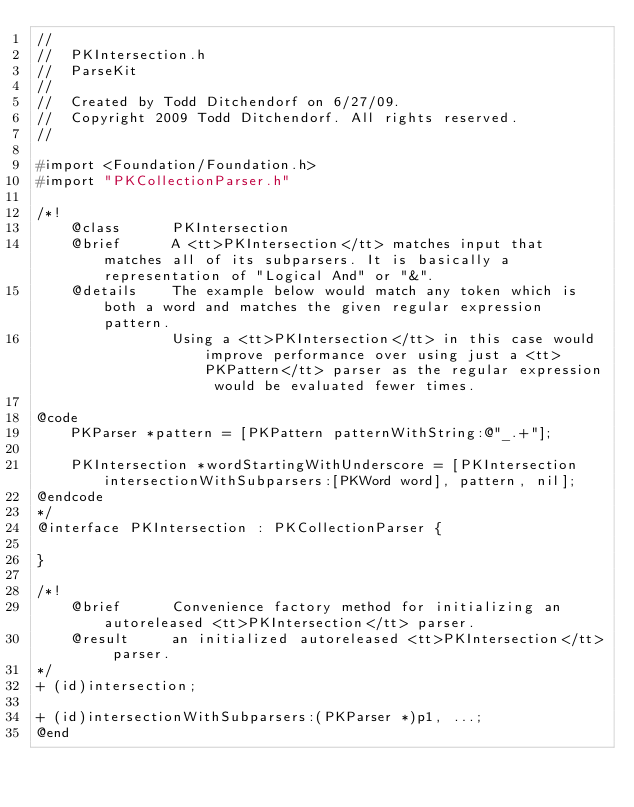Convert code to text. <code><loc_0><loc_0><loc_500><loc_500><_C_>//
//  PKIntersection.h
//  ParseKit
//
//  Created by Todd Ditchendorf on 6/27/09.
//  Copyright 2009 Todd Ditchendorf. All rights reserved.
//

#import <Foundation/Foundation.h>
#import "PKCollectionParser.h"

/*!
    @class      PKIntersection
    @brief      A <tt>PKIntersection</tt> matches input that matches all of its subparsers. It is basically a representation of "Logical And" or "&".
    @details    The example below would match any token which is both a word and matches the given regular expression pattern. 
                Using a <tt>PKIntersection</tt> in this case would improve performance over using just a <tt>PKPattern</tt> parser as the regular expression would be evaluated fewer times.
 
@code
    PKParser *pattern = [PKPattern patternWithString:@"_.+"];
 
    PKIntersection *wordStartingWithUnderscore = [PKIntersection intersectionWithSubparsers:[PKWord word], pattern, nil];
@endcode 
*/
@interface PKIntersection : PKCollectionParser {

}

/*!
    @brief      Convenience factory method for initializing an autoreleased <tt>PKIntersection</tt> parser.
    @result     an initialized autoreleased <tt>PKIntersection</tt> parser.
*/
+ (id)intersection;

+ (id)intersectionWithSubparsers:(PKParser *)p1, ...;
@end
</code> 